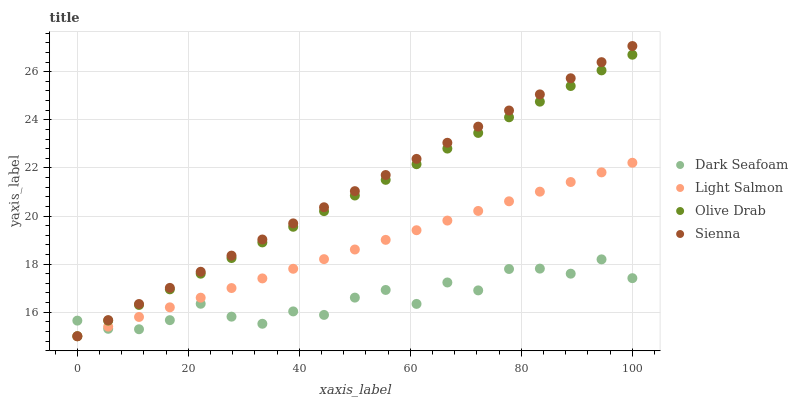Does Dark Seafoam have the minimum area under the curve?
Answer yes or no. Yes. Does Sienna have the maximum area under the curve?
Answer yes or no. Yes. Does Light Salmon have the minimum area under the curve?
Answer yes or no. No. Does Light Salmon have the maximum area under the curve?
Answer yes or no. No. Is Olive Drab the smoothest?
Answer yes or no. Yes. Is Dark Seafoam the roughest?
Answer yes or no. Yes. Is Light Salmon the smoothest?
Answer yes or no. No. Is Light Salmon the roughest?
Answer yes or no. No. Does Sienna have the lowest value?
Answer yes or no. Yes. Does Dark Seafoam have the lowest value?
Answer yes or no. No. Does Sienna have the highest value?
Answer yes or no. Yes. Does Light Salmon have the highest value?
Answer yes or no. No. Does Olive Drab intersect Light Salmon?
Answer yes or no. Yes. Is Olive Drab less than Light Salmon?
Answer yes or no. No. Is Olive Drab greater than Light Salmon?
Answer yes or no. No. 